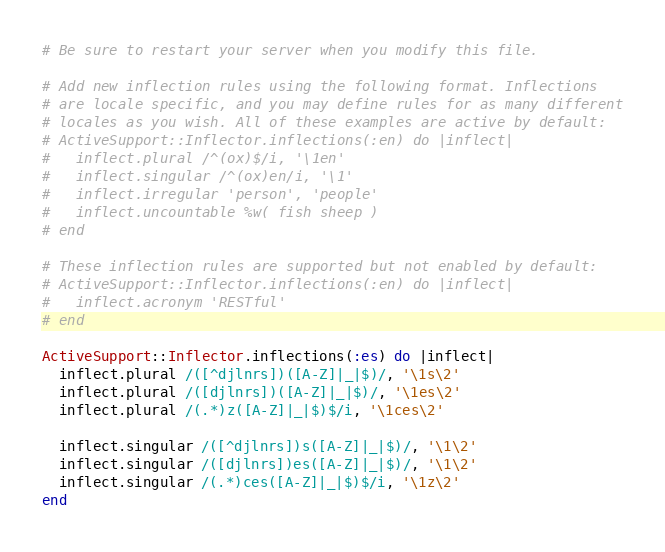Convert code to text. <code><loc_0><loc_0><loc_500><loc_500><_Ruby_># Be sure to restart your server when you modify this file.

# Add new inflection rules using the following format. Inflections
# are locale specific, and you may define rules for as many different
# locales as you wish. All of these examples are active by default:
# ActiveSupport::Inflector.inflections(:en) do |inflect|
#   inflect.plural /^(ox)$/i, '\1en'
#   inflect.singular /^(ox)en/i, '\1'
#   inflect.irregular 'person', 'people'
#   inflect.uncountable %w( fish sheep )
# end

# These inflection rules are supported but not enabled by default:
# ActiveSupport::Inflector.inflections(:en) do |inflect|
#   inflect.acronym 'RESTful'
# end

ActiveSupport::Inflector.inflections(:es) do |inflect|
  inflect.plural /([^djlnrs])([A-Z]|_|$)/, '\1s\2'
  inflect.plural /([djlnrs])([A-Z]|_|$)/, '\1es\2'
  inflect.plural /(.*)z([A-Z]|_|$)$/i, '\1ces\2'

  inflect.singular /([^djlnrs])s([A-Z]|_|$)/, '\1\2'
  inflect.singular /([djlnrs])es([A-Z]|_|$)/, '\1\2'
  inflect.singular /(.*)ces([A-Z]|_|$)$/i, '\1z\2'
end
</code> 